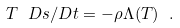<formula> <loc_0><loc_0><loc_500><loc_500>T \ D s / D t = - \rho \Lambda ( T ) \ .</formula> 